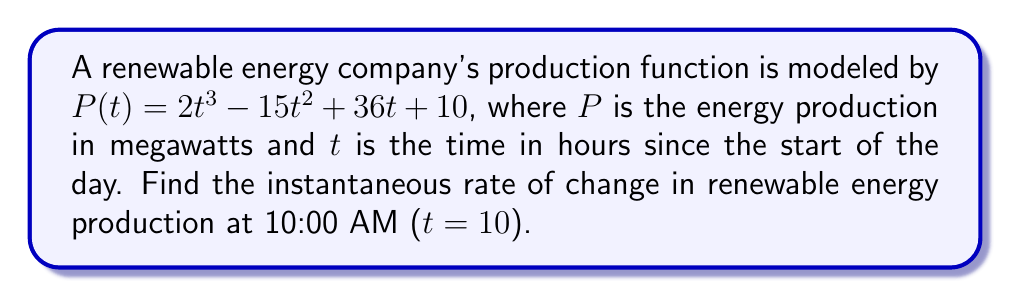Show me your answer to this math problem. To find the instantaneous rate of change, we need to calculate the derivative of the production function $P(t)$ and evaluate it at $t = 10$.

Step 1: Find the derivative of $P(t)$
$$\frac{d}{dt}P(t) = \frac{d}{dt}(2t^3 - 15t^2 + 36t + 10)$$
$$P'(t) = 6t^2 - 30t + 36$$

Step 2: Evaluate $P'(t)$ at $t = 10$
$$P'(10) = 6(10)^2 - 30(10) + 36$$
$$P'(10) = 6(100) - 300 + 36$$
$$P'(10) = 600 - 300 + 36$$
$$P'(10) = 336$$

The instantaneous rate of change at 10:00 AM (t = 10) is 336 megawatts per hour.
Answer: 336 MW/h 